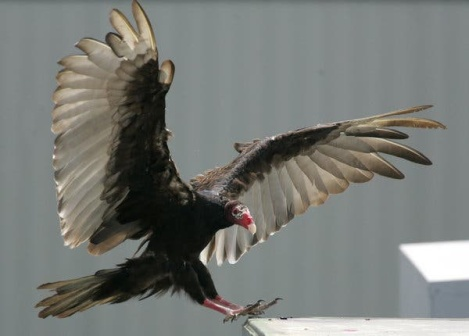Imagine a fantasy scenario involving this vulture. In a land where the skies shimmer with silver hues and the mountains whisper ancient secrets, the vulture is no ordinary bird. With wings spread wide, it is the celestial guardian of realms, tasked with carrying messages between the mystical aeries of the high mountains and the enchanted forests below. Its wings, imbued with the enchantments of storm spirits, shimmer with lightning as it soars through the clouds. The red of its head is the mark of the fire drakes, hinting at a noble lineage of dragons long disappeared. This vulture is on a quest, the fate of the realm woven into the fabric of its flight, and upon each wingspan rests the hopes of creatures bound to the earth. 